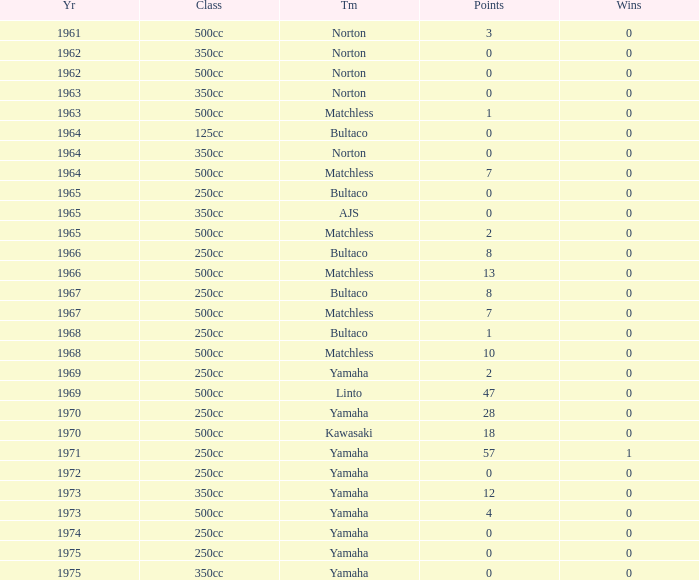What is the average wins in 250cc class for Bultaco with 8 points later than 1966? 0.0. 